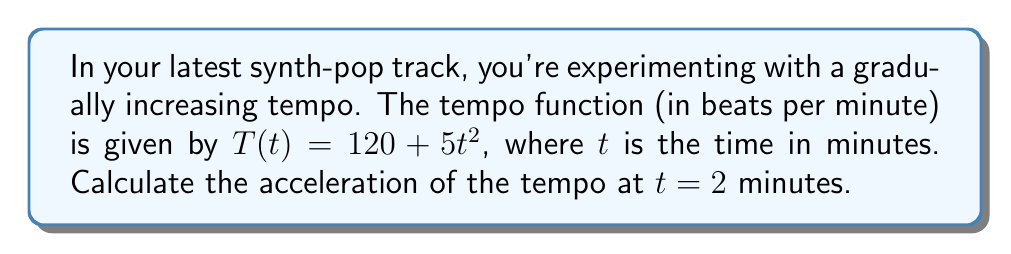Provide a solution to this math problem. To find the acceleration of the tempo, we need to calculate the second derivative of the tempo function $T(t)$.

Step 1: Find the first derivative (velocity of tempo change)
The first derivative represents the rate of change of tempo:
$$\frac{dT}{dt} = T'(t) = 10t$$

Step 2: Find the second derivative (acceleration of tempo change)
The second derivative represents the rate of change of the velocity, which is the acceleration:
$$\frac{d^2T}{dt^2} = T''(t) = 10$$

Step 3: Evaluate the acceleration at $t = 2$ minutes
Since the acceleration is constant (10), we don't need to substitute $t = 2$. The acceleration is always 10 beats per minute per minute.

Step 4: Interpret the result
This means the tempo is increasing at a constant rate of 10 beats per minute every minute, regardless of the time.
Answer: 10 beats/min² 